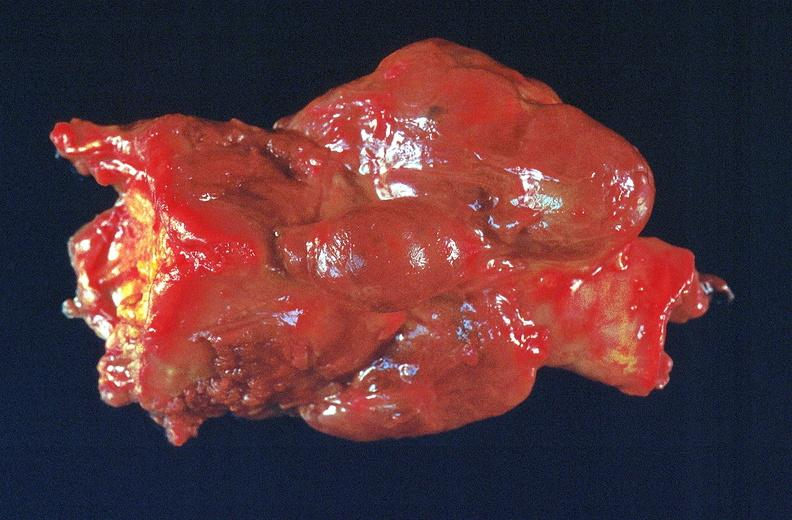where does this belong to?
Answer the question using a single word or phrase. Endocrine system 